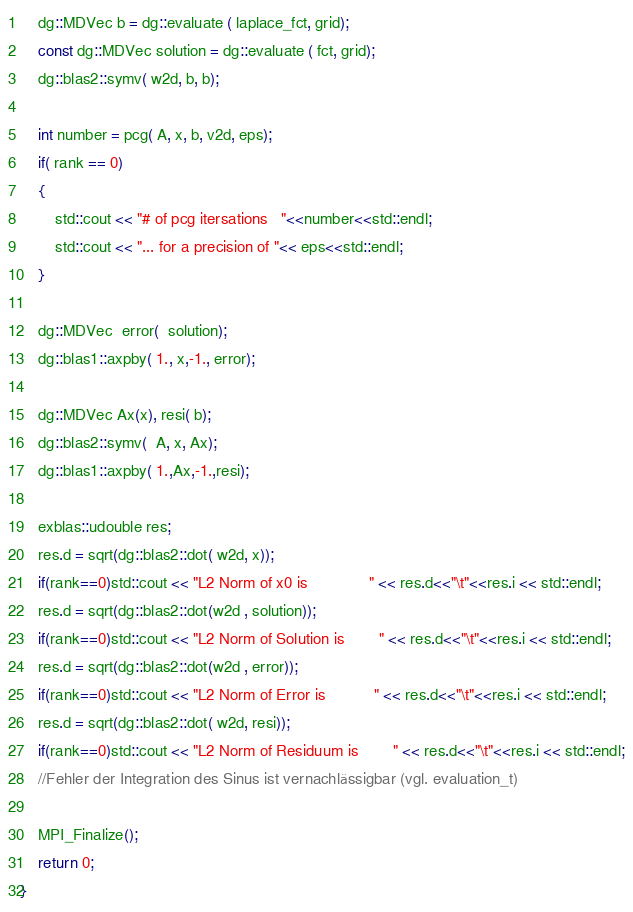<code> <loc_0><loc_0><loc_500><loc_500><_Cuda_>    dg::MDVec b = dg::evaluate ( laplace_fct, grid);
    const dg::MDVec solution = dg::evaluate ( fct, grid);
    dg::blas2::symv( w2d, b, b);

    int number = pcg( A, x, b, v2d, eps);
    if( rank == 0)
    {
        std::cout << "# of pcg itersations   "<<number<<std::endl;
        std::cout << "... for a precision of "<< eps<<std::endl;
    }

    dg::MDVec  error(  solution);
    dg::blas1::axpby( 1., x,-1., error);

    dg::MDVec Ax(x), resi( b);
    dg::blas2::symv(  A, x, Ax);
    dg::blas1::axpby( 1.,Ax,-1.,resi);

    exblas::udouble res;
    res.d = sqrt(dg::blas2::dot( w2d, x));
    if(rank==0)std::cout << "L2 Norm of x0 is              " << res.d<<"\t"<<res.i << std::endl;
    res.d = sqrt(dg::blas2::dot(w2d , solution));
    if(rank==0)std::cout << "L2 Norm of Solution is        " << res.d<<"\t"<<res.i << std::endl;
    res.d = sqrt(dg::blas2::dot(w2d , error));
    if(rank==0)std::cout << "L2 Norm of Error is           " << res.d<<"\t"<<res.i << std::endl;
    res.d = sqrt(dg::blas2::dot( w2d, resi));
    if(rank==0)std::cout << "L2 Norm of Residuum is        " << res.d<<"\t"<<res.i << std::endl;
    //Fehler der Integration des Sinus ist vernachlässigbar (vgl. evaluation_t)

    MPI_Finalize();
    return 0;
}
</code> 